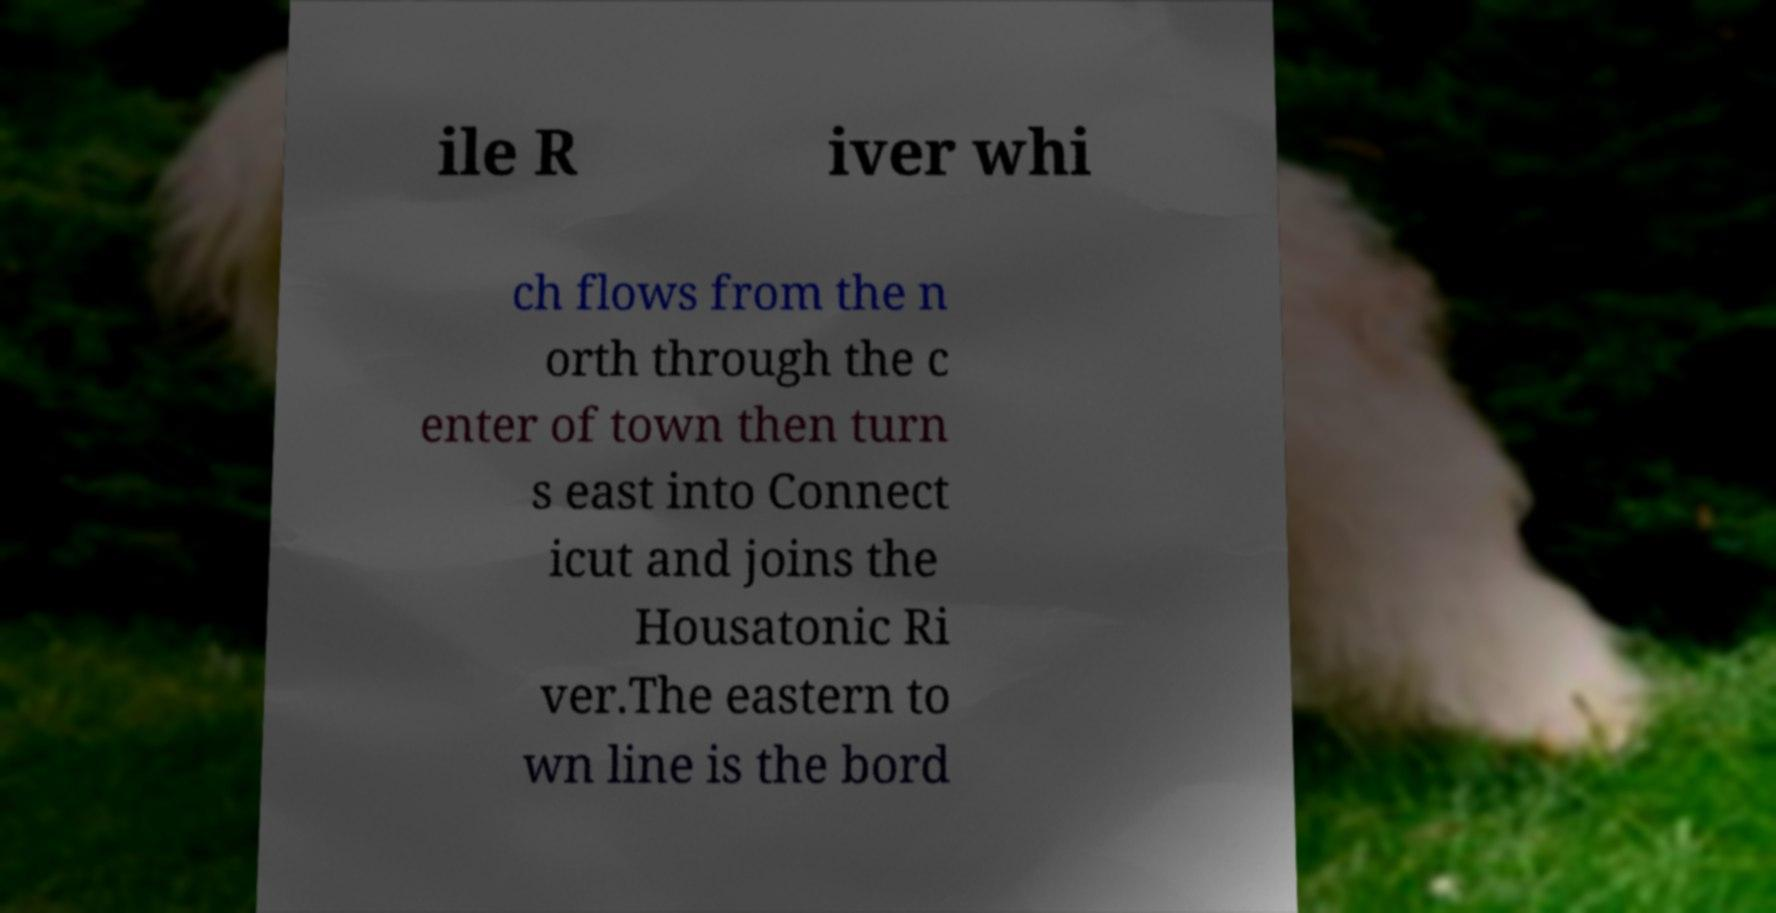What messages or text are displayed in this image? I need them in a readable, typed format. ile R iver whi ch flows from the n orth through the c enter of town then turn s east into Connect icut and joins the Housatonic Ri ver.The eastern to wn line is the bord 